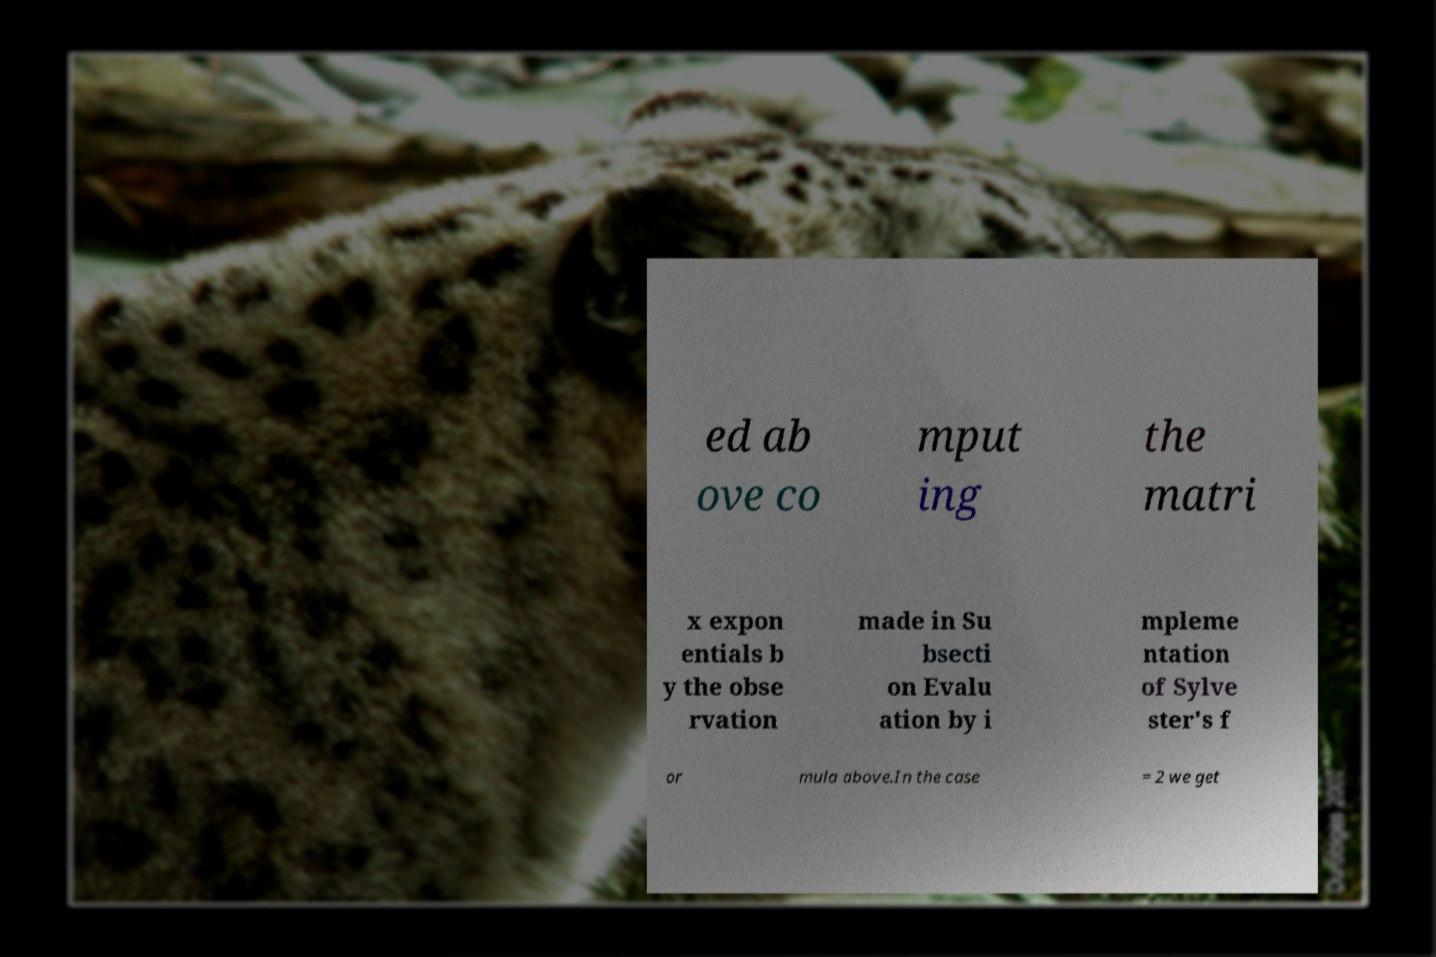Could you assist in decoding the text presented in this image and type it out clearly? ed ab ove co mput ing the matri x expon entials b y the obse rvation made in Su bsecti on Evalu ation by i mpleme ntation of Sylve ster's f or mula above.In the case = 2 we get 